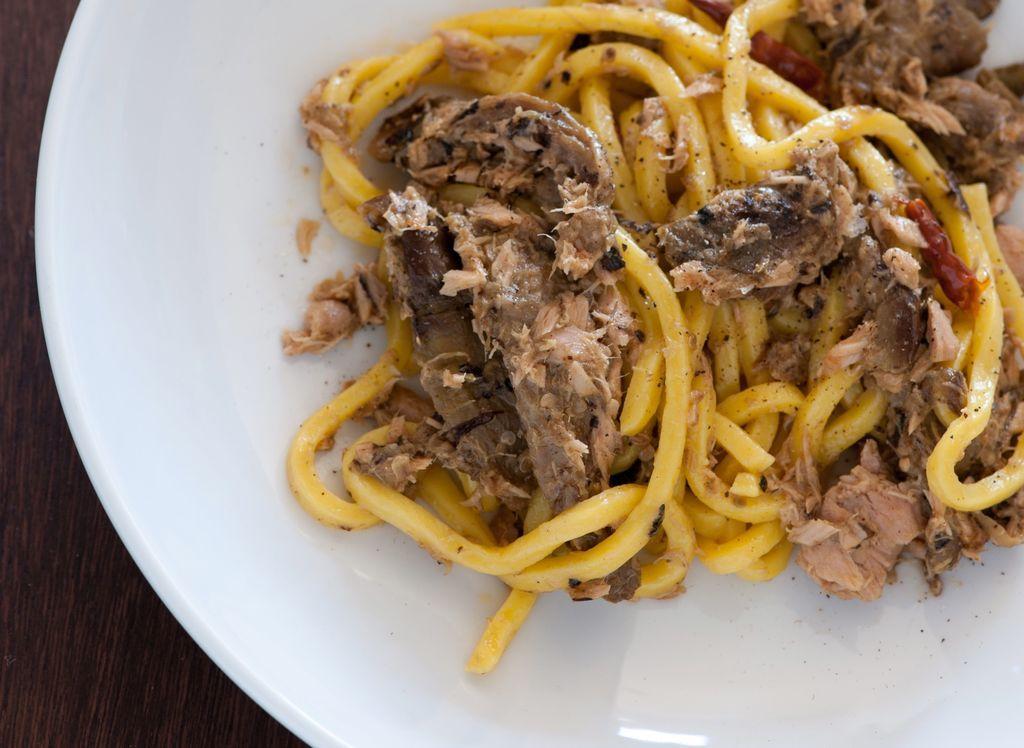How would you summarize this image in a sentence or two? In this image I can see food is on the white plate. White plate is kept on the wooden surface.   